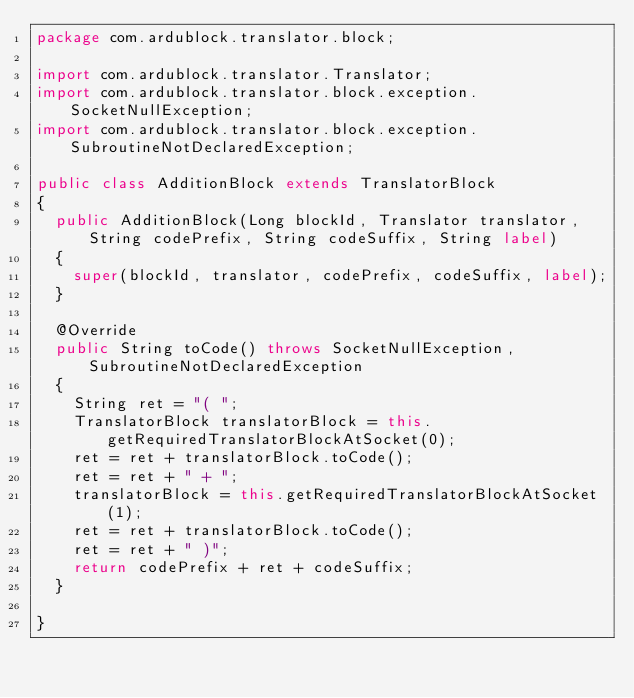<code> <loc_0><loc_0><loc_500><loc_500><_Java_>package com.ardublock.translator.block;

import com.ardublock.translator.Translator;
import com.ardublock.translator.block.exception.SocketNullException;
import com.ardublock.translator.block.exception.SubroutineNotDeclaredException;

public class AdditionBlock extends TranslatorBlock
{
	public AdditionBlock(Long blockId, Translator translator, String codePrefix, String codeSuffix, String label)
	{
		super(blockId, translator, codePrefix, codeSuffix, label);
	}

	@Override
	public String toCode() throws SocketNullException, SubroutineNotDeclaredException
	{
		String ret = "( ";
		TranslatorBlock translatorBlock = this.getRequiredTranslatorBlockAtSocket(0);
		ret = ret + translatorBlock.toCode();
		ret = ret + " + ";
		translatorBlock = this.getRequiredTranslatorBlockAtSocket(1);
		ret = ret + translatorBlock.toCode();
		ret = ret + " )";
		return codePrefix + ret + codeSuffix;
	}

}
</code> 